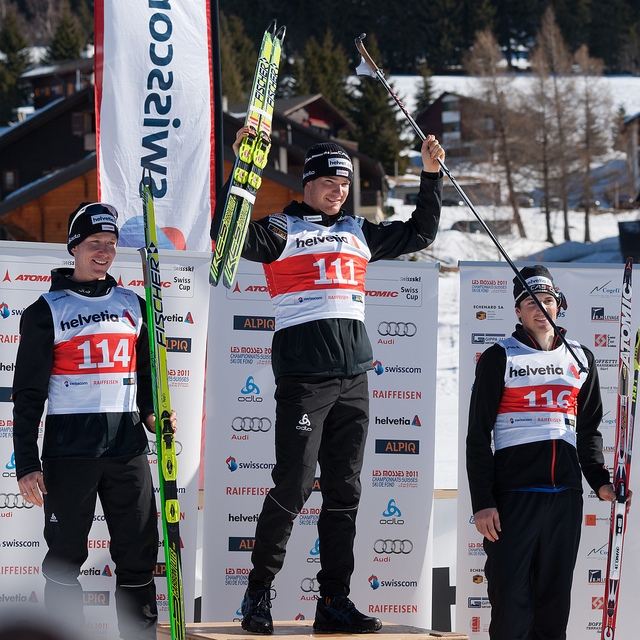Describe the scene depicted in this photograph. The image captures a moment of celebration at a sporting event award ceremony, with three athletes standing on a podium. The individual in the center stands on the highest level and is raising an arm in triumph, holding a ski pole. The person is flanked by two other athletes on lower levels of the podium, each displaying a reserved smile. All are wearing athletic attire, and there are signs and sponsor logos visible in the background, indicating the event's support and venue. 